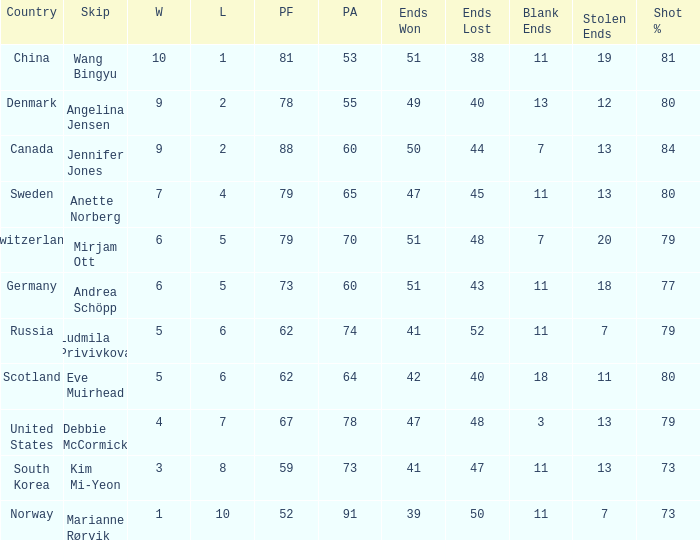What is norway's tiniest ends disappeared? 50.0. 